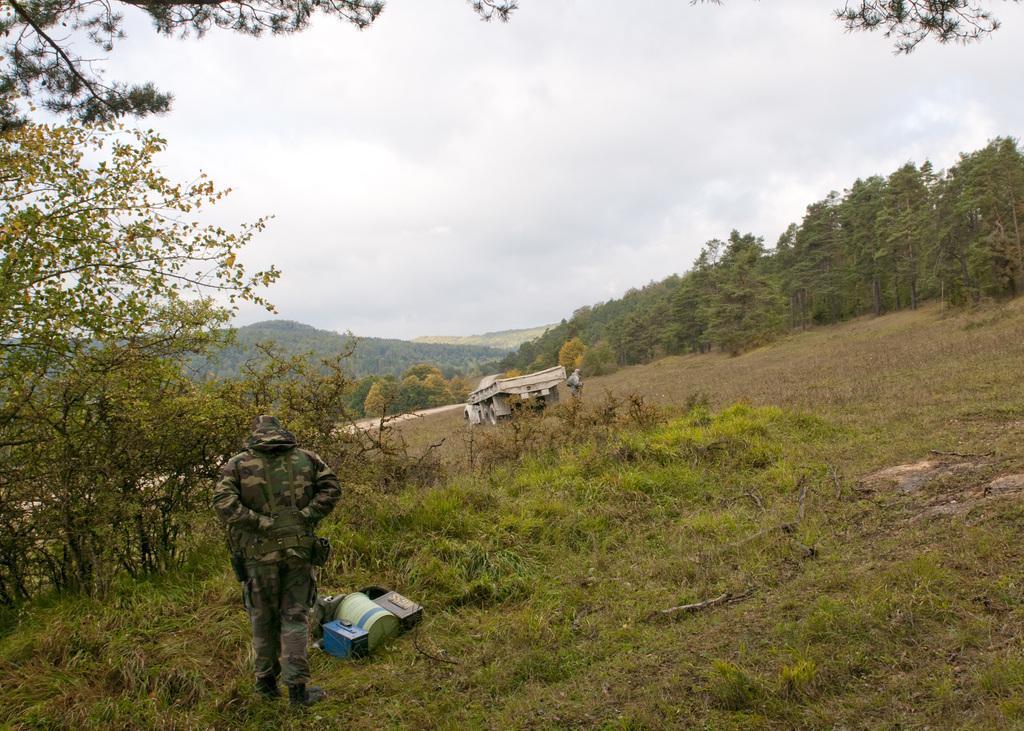Could you give a brief overview of what you see in this image? In this image there is the sky, there are mountains, there are trees, there are plants, there is grass, there is a vehicle, there is an object on the ground, there is a person standing, there is a tree truncated towards the left of the image, there is a tree truncated towards the right of the image, there are trees truncated at the top of the image. 